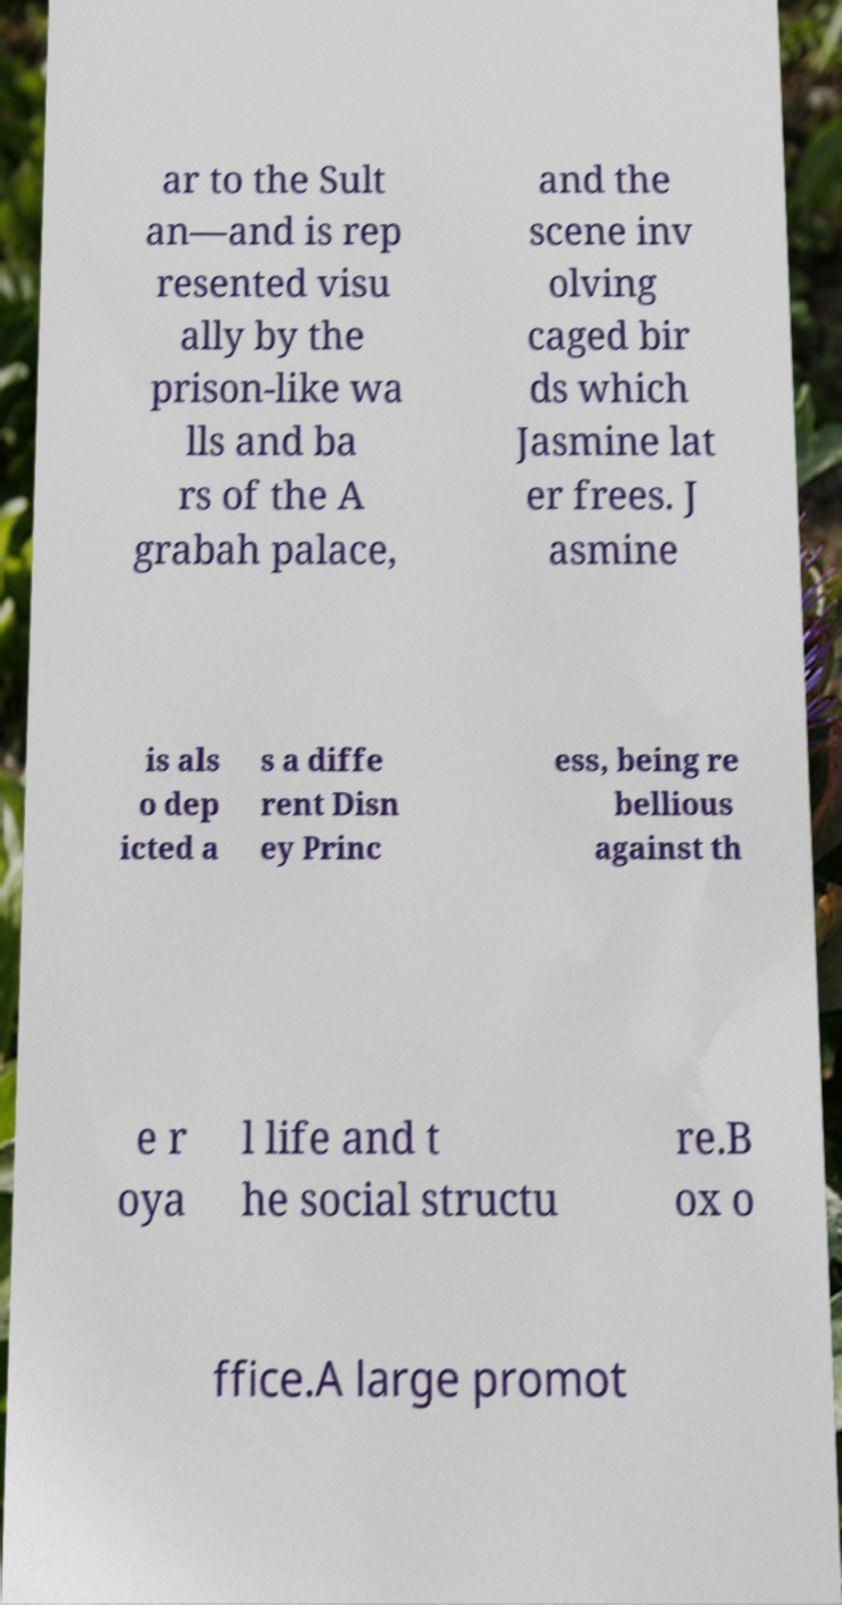What messages or text are displayed in this image? I need them in a readable, typed format. ar to the Sult an—and is rep resented visu ally by the prison-like wa lls and ba rs of the A grabah palace, and the scene inv olving caged bir ds which Jasmine lat er frees. J asmine is als o dep icted a s a diffe rent Disn ey Princ ess, being re bellious against th e r oya l life and t he social structu re.B ox o ffice.A large promot 